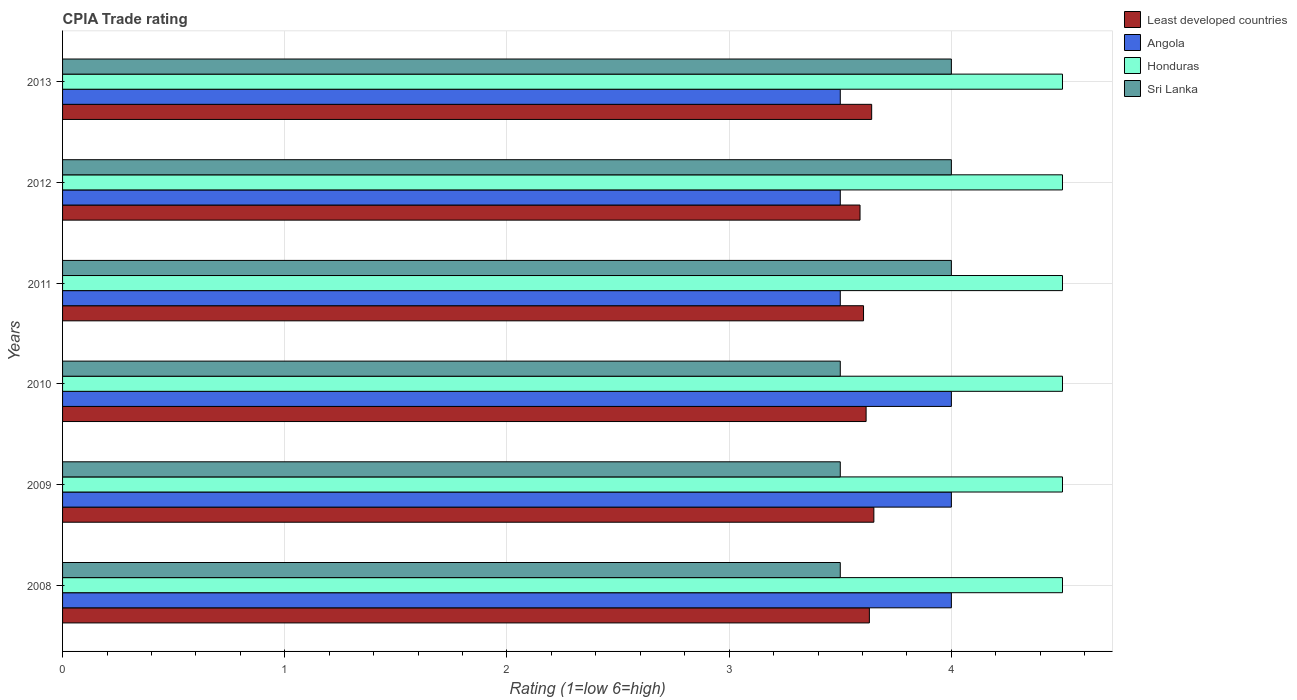How many different coloured bars are there?
Ensure brevity in your answer.  4. How many groups of bars are there?
Your answer should be very brief. 6. Are the number of bars on each tick of the Y-axis equal?
Offer a terse response. Yes. How many bars are there on the 4th tick from the bottom?
Offer a terse response. 4. What is the label of the 5th group of bars from the top?
Keep it short and to the point. 2009. In how many cases, is the number of bars for a given year not equal to the number of legend labels?
Offer a terse response. 0. Across all years, what is the minimum CPIA rating in Honduras?
Ensure brevity in your answer.  4.5. In which year was the CPIA rating in Honduras maximum?
Ensure brevity in your answer.  2008. What is the difference between the CPIA rating in Least developed countries in 2011 and that in 2013?
Keep it short and to the point. -0.04. What is the average CPIA rating in Sri Lanka per year?
Ensure brevity in your answer.  3.75. In the year 2008, what is the difference between the CPIA rating in Sri Lanka and CPIA rating in Least developed countries?
Offer a terse response. -0.13. In how many years, is the CPIA rating in Honduras greater than 2 ?
Give a very brief answer. 6. What is the ratio of the CPIA rating in Angola in 2012 to that in 2013?
Your response must be concise. 1. What is the difference between the highest and the second highest CPIA rating in Least developed countries?
Offer a terse response. 0.01. What is the difference between the highest and the lowest CPIA rating in Sri Lanka?
Ensure brevity in your answer.  0.5. In how many years, is the CPIA rating in Least developed countries greater than the average CPIA rating in Least developed countries taken over all years?
Make the answer very short. 3. Is it the case that in every year, the sum of the CPIA rating in Honduras and CPIA rating in Sri Lanka is greater than the sum of CPIA rating in Angola and CPIA rating in Least developed countries?
Give a very brief answer. Yes. What does the 1st bar from the top in 2009 represents?
Ensure brevity in your answer.  Sri Lanka. What does the 1st bar from the bottom in 2013 represents?
Provide a succinct answer. Least developed countries. Is it the case that in every year, the sum of the CPIA rating in Sri Lanka and CPIA rating in Honduras is greater than the CPIA rating in Least developed countries?
Offer a very short reply. Yes. Are all the bars in the graph horizontal?
Your response must be concise. Yes. What is the difference between two consecutive major ticks on the X-axis?
Your answer should be compact. 1. Are the values on the major ticks of X-axis written in scientific E-notation?
Give a very brief answer. No. Does the graph contain grids?
Offer a very short reply. Yes. Where does the legend appear in the graph?
Your answer should be compact. Top right. How many legend labels are there?
Ensure brevity in your answer.  4. What is the title of the graph?
Give a very brief answer. CPIA Trade rating. What is the label or title of the X-axis?
Provide a short and direct response. Rating (1=low 6=high). What is the label or title of the Y-axis?
Your response must be concise. Years. What is the Rating (1=low 6=high) in Least developed countries in 2008?
Provide a short and direct response. 3.63. What is the Rating (1=low 6=high) of Honduras in 2008?
Offer a terse response. 4.5. What is the Rating (1=low 6=high) of Sri Lanka in 2008?
Make the answer very short. 3.5. What is the Rating (1=low 6=high) of Least developed countries in 2009?
Keep it short and to the point. 3.65. What is the Rating (1=low 6=high) of Angola in 2009?
Your response must be concise. 4. What is the Rating (1=low 6=high) in Honduras in 2009?
Make the answer very short. 4.5. What is the Rating (1=low 6=high) of Least developed countries in 2010?
Your response must be concise. 3.62. What is the Rating (1=low 6=high) of Angola in 2010?
Give a very brief answer. 4. What is the Rating (1=low 6=high) of Least developed countries in 2011?
Your response must be concise. 3.6. What is the Rating (1=low 6=high) of Angola in 2011?
Provide a succinct answer. 3.5. What is the Rating (1=low 6=high) of Honduras in 2011?
Offer a terse response. 4.5. What is the Rating (1=low 6=high) of Least developed countries in 2012?
Your response must be concise. 3.59. What is the Rating (1=low 6=high) of Sri Lanka in 2012?
Offer a terse response. 4. What is the Rating (1=low 6=high) of Least developed countries in 2013?
Offer a very short reply. 3.64. What is the Rating (1=low 6=high) in Angola in 2013?
Your answer should be compact. 3.5. What is the Rating (1=low 6=high) in Sri Lanka in 2013?
Offer a very short reply. 4. Across all years, what is the maximum Rating (1=low 6=high) of Least developed countries?
Make the answer very short. 3.65. Across all years, what is the maximum Rating (1=low 6=high) in Angola?
Offer a terse response. 4. Across all years, what is the maximum Rating (1=low 6=high) of Honduras?
Provide a succinct answer. 4.5. Across all years, what is the maximum Rating (1=low 6=high) of Sri Lanka?
Provide a short and direct response. 4. Across all years, what is the minimum Rating (1=low 6=high) in Least developed countries?
Keep it short and to the point. 3.59. Across all years, what is the minimum Rating (1=low 6=high) in Angola?
Give a very brief answer. 3.5. Across all years, what is the minimum Rating (1=low 6=high) of Honduras?
Your answer should be very brief. 4.5. What is the total Rating (1=low 6=high) in Least developed countries in the graph?
Provide a short and direct response. 21.73. What is the total Rating (1=low 6=high) of Angola in the graph?
Your answer should be compact. 22.5. What is the total Rating (1=low 6=high) of Sri Lanka in the graph?
Offer a terse response. 22.5. What is the difference between the Rating (1=low 6=high) in Least developed countries in 2008 and that in 2009?
Ensure brevity in your answer.  -0.02. What is the difference between the Rating (1=low 6=high) of Honduras in 2008 and that in 2009?
Offer a very short reply. 0. What is the difference between the Rating (1=low 6=high) of Least developed countries in 2008 and that in 2010?
Ensure brevity in your answer.  0.01. What is the difference between the Rating (1=low 6=high) in Angola in 2008 and that in 2010?
Ensure brevity in your answer.  0. What is the difference between the Rating (1=low 6=high) of Honduras in 2008 and that in 2010?
Keep it short and to the point. 0. What is the difference between the Rating (1=low 6=high) of Least developed countries in 2008 and that in 2011?
Your answer should be compact. 0.03. What is the difference between the Rating (1=low 6=high) in Honduras in 2008 and that in 2011?
Offer a very short reply. 0. What is the difference between the Rating (1=low 6=high) of Least developed countries in 2008 and that in 2012?
Provide a short and direct response. 0.04. What is the difference between the Rating (1=low 6=high) in Honduras in 2008 and that in 2012?
Provide a succinct answer. 0. What is the difference between the Rating (1=low 6=high) of Least developed countries in 2008 and that in 2013?
Your response must be concise. -0.01. What is the difference between the Rating (1=low 6=high) in Honduras in 2008 and that in 2013?
Give a very brief answer. 0. What is the difference between the Rating (1=low 6=high) of Least developed countries in 2009 and that in 2010?
Your response must be concise. 0.03. What is the difference between the Rating (1=low 6=high) in Angola in 2009 and that in 2010?
Your answer should be compact. 0. What is the difference between the Rating (1=low 6=high) of Sri Lanka in 2009 and that in 2010?
Your response must be concise. 0. What is the difference between the Rating (1=low 6=high) in Least developed countries in 2009 and that in 2011?
Your response must be concise. 0.05. What is the difference between the Rating (1=low 6=high) of Angola in 2009 and that in 2011?
Provide a short and direct response. 0.5. What is the difference between the Rating (1=low 6=high) of Honduras in 2009 and that in 2011?
Offer a terse response. 0. What is the difference between the Rating (1=low 6=high) in Sri Lanka in 2009 and that in 2011?
Provide a short and direct response. -0.5. What is the difference between the Rating (1=low 6=high) of Least developed countries in 2009 and that in 2012?
Your response must be concise. 0.06. What is the difference between the Rating (1=low 6=high) of Angola in 2009 and that in 2012?
Your answer should be compact. 0.5. What is the difference between the Rating (1=low 6=high) in Sri Lanka in 2009 and that in 2012?
Offer a terse response. -0.5. What is the difference between the Rating (1=low 6=high) in Least developed countries in 2009 and that in 2013?
Make the answer very short. 0.01. What is the difference between the Rating (1=low 6=high) of Least developed countries in 2010 and that in 2011?
Your answer should be compact. 0.01. What is the difference between the Rating (1=low 6=high) of Least developed countries in 2010 and that in 2012?
Provide a succinct answer. 0.03. What is the difference between the Rating (1=low 6=high) of Sri Lanka in 2010 and that in 2012?
Make the answer very short. -0.5. What is the difference between the Rating (1=low 6=high) of Least developed countries in 2010 and that in 2013?
Make the answer very short. -0.03. What is the difference between the Rating (1=low 6=high) in Angola in 2010 and that in 2013?
Offer a terse response. 0.5. What is the difference between the Rating (1=low 6=high) of Honduras in 2010 and that in 2013?
Provide a short and direct response. 0. What is the difference between the Rating (1=low 6=high) in Sri Lanka in 2010 and that in 2013?
Make the answer very short. -0.5. What is the difference between the Rating (1=low 6=high) in Least developed countries in 2011 and that in 2012?
Make the answer very short. 0.02. What is the difference between the Rating (1=low 6=high) of Honduras in 2011 and that in 2012?
Keep it short and to the point. 0. What is the difference between the Rating (1=low 6=high) of Sri Lanka in 2011 and that in 2012?
Provide a succinct answer. 0. What is the difference between the Rating (1=low 6=high) in Least developed countries in 2011 and that in 2013?
Your response must be concise. -0.04. What is the difference between the Rating (1=low 6=high) of Angola in 2011 and that in 2013?
Your answer should be compact. 0. What is the difference between the Rating (1=low 6=high) in Sri Lanka in 2011 and that in 2013?
Offer a very short reply. 0. What is the difference between the Rating (1=low 6=high) in Least developed countries in 2012 and that in 2013?
Make the answer very short. -0.05. What is the difference between the Rating (1=low 6=high) of Honduras in 2012 and that in 2013?
Provide a succinct answer. 0. What is the difference between the Rating (1=low 6=high) in Sri Lanka in 2012 and that in 2013?
Provide a succinct answer. 0. What is the difference between the Rating (1=low 6=high) of Least developed countries in 2008 and the Rating (1=low 6=high) of Angola in 2009?
Your response must be concise. -0.37. What is the difference between the Rating (1=low 6=high) in Least developed countries in 2008 and the Rating (1=low 6=high) in Honduras in 2009?
Your answer should be compact. -0.87. What is the difference between the Rating (1=low 6=high) in Least developed countries in 2008 and the Rating (1=low 6=high) in Sri Lanka in 2009?
Your answer should be very brief. 0.13. What is the difference between the Rating (1=low 6=high) of Least developed countries in 2008 and the Rating (1=low 6=high) of Angola in 2010?
Provide a short and direct response. -0.37. What is the difference between the Rating (1=low 6=high) in Least developed countries in 2008 and the Rating (1=low 6=high) in Honduras in 2010?
Your answer should be very brief. -0.87. What is the difference between the Rating (1=low 6=high) of Least developed countries in 2008 and the Rating (1=low 6=high) of Sri Lanka in 2010?
Provide a succinct answer. 0.13. What is the difference between the Rating (1=low 6=high) of Angola in 2008 and the Rating (1=low 6=high) of Sri Lanka in 2010?
Offer a terse response. 0.5. What is the difference between the Rating (1=low 6=high) in Least developed countries in 2008 and the Rating (1=low 6=high) in Angola in 2011?
Your answer should be compact. 0.13. What is the difference between the Rating (1=low 6=high) of Least developed countries in 2008 and the Rating (1=low 6=high) of Honduras in 2011?
Ensure brevity in your answer.  -0.87. What is the difference between the Rating (1=low 6=high) of Least developed countries in 2008 and the Rating (1=low 6=high) of Sri Lanka in 2011?
Ensure brevity in your answer.  -0.37. What is the difference between the Rating (1=low 6=high) in Least developed countries in 2008 and the Rating (1=low 6=high) in Angola in 2012?
Your answer should be compact. 0.13. What is the difference between the Rating (1=low 6=high) in Least developed countries in 2008 and the Rating (1=low 6=high) in Honduras in 2012?
Your answer should be compact. -0.87. What is the difference between the Rating (1=low 6=high) of Least developed countries in 2008 and the Rating (1=low 6=high) of Sri Lanka in 2012?
Keep it short and to the point. -0.37. What is the difference between the Rating (1=low 6=high) of Honduras in 2008 and the Rating (1=low 6=high) of Sri Lanka in 2012?
Your answer should be compact. 0.5. What is the difference between the Rating (1=low 6=high) of Least developed countries in 2008 and the Rating (1=low 6=high) of Angola in 2013?
Offer a very short reply. 0.13. What is the difference between the Rating (1=low 6=high) of Least developed countries in 2008 and the Rating (1=low 6=high) of Honduras in 2013?
Give a very brief answer. -0.87. What is the difference between the Rating (1=low 6=high) in Least developed countries in 2008 and the Rating (1=low 6=high) in Sri Lanka in 2013?
Provide a succinct answer. -0.37. What is the difference between the Rating (1=low 6=high) in Angola in 2008 and the Rating (1=low 6=high) in Honduras in 2013?
Provide a short and direct response. -0.5. What is the difference between the Rating (1=low 6=high) of Honduras in 2008 and the Rating (1=low 6=high) of Sri Lanka in 2013?
Give a very brief answer. 0.5. What is the difference between the Rating (1=low 6=high) in Least developed countries in 2009 and the Rating (1=low 6=high) in Angola in 2010?
Your answer should be very brief. -0.35. What is the difference between the Rating (1=low 6=high) in Least developed countries in 2009 and the Rating (1=low 6=high) in Honduras in 2010?
Provide a succinct answer. -0.85. What is the difference between the Rating (1=low 6=high) of Least developed countries in 2009 and the Rating (1=low 6=high) of Sri Lanka in 2010?
Provide a short and direct response. 0.15. What is the difference between the Rating (1=low 6=high) in Angola in 2009 and the Rating (1=low 6=high) in Honduras in 2010?
Give a very brief answer. -0.5. What is the difference between the Rating (1=low 6=high) in Honduras in 2009 and the Rating (1=low 6=high) in Sri Lanka in 2010?
Ensure brevity in your answer.  1. What is the difference between the Rating (1=low 6=high) of Least developed countries in 2009 and the Rating (1=low 6=high) of Angola in 2011?
Provide a short and direct response. 0.15. What is the difference between the Rating (1=low 6=high) in Least developed countries in 2009 and the Rating (1=low 6=high) in Honduras in 2011?
Your response must be concise. -0.85. What is the difference between the Rating (1=low 6=high) of Least developed countries in 2009 and the Rating (1=low 6=high) of Sri Lanka in 2011?
Give a very brief answer. -0.35. What is the difference between the Rating (1=low 6=high) in Angola in 2009 and the Rating (1=low 6=high) in Honduras in 2011?
Offer a terse response. -0.5. What is the difference between the Rating (1=low 6=high) of Angola in 2009 and the Rating (1=low 6=high) of Sri Lanka in 2011?
Your answer should be compact. 0. What is the difference between the Rating (1=low 6=high) of Honduras in 2009 and the Rating (1=low 6=high) of Sri Lanka in 2011?
Your answer should be very brief. 0.5. What is the difference between the Rating (1=low 6=high) of Least developed countries in 2009 and the Rating (1=low 6=high) of Angola in 2012?
Offer a terse response. 0.15. What is the difference between the Rating (1=low 6=high) in Least developed countries in 2009 and the Rating (1=low 6=high) in Honduras in 2012?
Ensure brevity in your answer.  -0.85. What is the difference between the Rating (1=low 6=high) of Least developed countries in 2009 and the Rating (1=low 6=high) of Sri Lanka in 2012?
Provide a short and direct response. -0.35. What is the difference between the Rating (1=low 6=high) in Angola in 2009 and the Rating (1=low 6=high) in Honduras in 2012?
Offer a very short reply. -0.5. What is the difference between the Rating (1=low 6=high) in Honduras in 2009 and the Rating (1=low 6=high) in Sri Lanka in 2012?
Provide a succinct answer. 0.5. What is the difference between the Rating (1=low 6=high) in Least developed countries in 2009 and the Rating (1=low 6=high) in Angola in 2013?
Provide a succinct answer. 0.15. What is the difference between the Rating (1=low 6=high) in Least developed countries in 2009 and the Rating (1=low 6=high) in Honduras in 2013?
Give a very brief answer. -0.85. What is the difference between the Rating (1=low 6=high) in Least developed countries in 2009 and the Rating (1=low 6=high) in Sri Lanka in 2013?
Make the answer very short. -0.35. What is the difference between the Rating (1=low 6=high) in Honduras in 2009 and the Rating (1=low 6=high) in Sri Lanka in 2013?
Give a very brief answer. 0.5. What is the difference between the Rating (1=low 6=high) of Least developed countries in 2010 and the Rating (1=low 6=high) of Angola in 2011?
Make the answer very short. 0.12. What is the difference between the Rating (1=low 6=high) of Least developed countries in 2010 and the Rating (1=low 6=high) of Honduras in 2011?
Your answer should be compact. -0.88. What is the difference between the Rating (1=low 6=high) of Least developed countries in 2010 and the Rating (1=low 6=high) of Sri Lanka in 2011?
Your answer should be very brief. -0.38. What is the difference between the Rating (1=low 6=high) in Angola in 2010 and the Rating (1=low 6=high) in Honduras in 2011?
Your answer should be compact. -0.5. What is the difference between the Rating (1=low 6=high) of Angola in 2010 and the Rating (1=low 6=high) of Sri Lanka in 2011?
Offer a terse response. 0. What is the difference between the Rating (1=low 6=high) of Honduras in 2010 and the Rating (1=low 6=high) of Sri Lanka in 2011?
Give a very brief answer. 0.5. What is the difference between the Rating (1=low 6=high) of Least developed countries in 2010 and the Rating (1=low 6=high) of Angola in 2012?
Ensure brevity in your answer.  0.12. What is the difference between the Rating (1=low 6=high) of Least developed countries in 2010 and the Rating (1=low 6=high) of Honduras in 2012?
Your answer should be compact. -0.88. What is the difference between the Rating (1=low 6=high) of Least developed countries in 2010 and the Rating (1=low 6=high) of Sri Lanka in 2012?
Your response must be concise. -0.38. What is the difference between the Rating (1=low 6=high) of Angola in 2010 and the Rating (1=low 6=high) of Honduras in 2012?
Keep it short and to the point. -0.5. What is the difference between the Rating (1=low 6=high) of Angola in 2010 and the Rating (1=low 6=high) of Sri Lanka in 2012?
Your answer should be very brief. 0. What is the difference between the Rating (1=low 6=high) in Honduras in 2010 and the Rating (1=low 6=high) in Sri Lanka in 2012?
Your answer should be very brief. 0.5. What is the difference between the Rating (1=low 6=high) of Least developed countries in 2010 and the Rating (1=low 6=high) of Angola in 2013?
Your answer should be very brief. 0.12. What is the difference between the Rating (1=low 6=high) of Least developed countries in 2010 and the Rating (1=low 6=high) of Honduras in 2013?
Your answer should be very brief. -0.88. What is the difference between the Rating (1=low 6=high) in Least developed countries in 2010 and the Rating (1=low 6=high) in Sri Lanka in 2013?
Your answer should be compact. -0.38. What is the difference between the Rating (1=low 6=high) of Honduras in 2010 and the Rating (1=low 6=high) of Sri Lanka in 2013?
Provide a succinct answer. 0.5. What is the difference between the Rating (1=low 6=high) in Least developed countries in 2011 and the Rating (1=low 6=high) in Angola in 2012?
Your answer should be compact. 0.1. What is the difference between the Rating (1=low 6=high) of Least developed countries in 2011 and the Rating (1=low 6=high) of Honduras in 2012?
Your answer should be very brief. -0.9. What is the difference between the Rating (1=low 6=high) of Least developed countries in 2011 and the Rating (1=low 6=high) of Sri Lanka in 2012?
Provide a succinct answer. -0.4. What is the difference between the Rating (1=low 6=high) in Angola in 2011 and the Rating (1=low 6=high) in Honduras in 2012?
Keep it short and to the point. -1. What is the difference between the Rating (1=low 6=high) in Angola in 2011 and the Rating (1=low 6=high) in Sri Lanka in 2012?
Keep it short and to the point. -0.5. What is the difference between the Rating (1=low 6=high) of Honduras in 2011 and the Rating (1=low 6=high) of Sri Lanka in 2012?
Offer a terse response. 0.5. What is the difference between the Rating (1=low 6=high) of Least developed countries in 2011 and the Rating (1=low 6=high) of Angola in 2013?
Provide a short and direct response. 0.1. What is the difference between the Rating (1=low 6=high) in Least developed countries in 2011 and the Rating (1=low 6=high) in Honduras in 2013?
Your response must be concise. -0.9. What is the difference between the Rating (1=low 6=high) in Least developed countries in 2011 and the Rating (1=low 6=high) in Sri Lanka in 2013?
Offer a terse response. -0.4. What is the difference between the Rating (1=low 6=high) in Angola in 2011 and the Rating (1=low 6=high) in Honduras in 2013?
Your response must be concise. -1. What is the difference between the Rating (1=low 6=high) in Angola in 2011 and the Rating (1=low 6=high) in Sri Lanka in 2013?
Offer a terse response. -0.5. What is the difference between the Rating (1=low 6=high) in Honduras in 2011 and the Rating (1=low 6=high) in Sri Lanka in 2013?
Provide a short and direct response. 0.5. What is the difference between the Rating (1=low 6=high) of Least developed countries in 2012 and the Rating (1=low 6=high) of Angola in 2013?
Provide a short and direct response. 0.09. What is the difference between the Rating (1=low 6=high) of Least developed countries in 2012 and the Rating (1=low 6=high) of Honduras in 2013?
Your response must be concise. -0.91. What is the difference between the Rating (1=low 6=high) of Least developed countries in 2012 and the Rating (1=low 6=high) of Sri Lanka in 2013?
Keep it short and to the point. -0.41. What is the difference between the Rating (1=low 6=high) of Honduras in 2012 and the Rating (1=low 6=high) of Sri Lanka in 2013?
Ensure brevity in your answer.  0.5. What is the average Rating (1=low 6=high) in Least developed countries per year?
Your answer should be very brief. 3.62. What is the average Rating (1=low 6=high) of Angola per year?
Ensure brevity in your answer.  3.75. What is the average Rating (1=low 6=high) in Sri Lanka per year?
Ensure brevity in your answer.  3.75. In the year 2008, what is the difference between the Rating (1=low 6=high) of Least developed countries and Rating (1=low 6=high) of Angola?
Your response must be concise. -0.37. In the year 2008, what is the difference between the Rating (1=low 6=high) in Least developed countries and Rating (1=low 6=high) in Honduras?
Provide a succinct answer. -0.87. In the year 2008, what is the difference between the Rating (1=low 6=high) in Least developed countries and Rating (1=low 6=high) in Sri Lanka?
Make the answer very short. 0.13. In the year 2008, what is the difference between the Rating (1=low 6=high) of Angola and Rating (1=low 6=high) of Honduras?
Keep it short and to the point. -0.5. In the year 2008, what is the difference between the Rating (1=low 6=high) of Honduras and Rating (1=low 6=high) of Sri Lanka?
Your answer should be compact. 1. In the year 2009, what is the difference between the Rating (1=low 6=high) of Least developed countries and Rating (1=low 6=high) of Angola?
Keep it short and to the point. -0.35. In the year 2009, what is the difference between the Rating (1=low 6=high) of Least developed countries and Rating (1=low 6=high) of Honduras?
Offer a very short reply. -0.85. In the year 2009, what is the difference between the Rating (1=low 6=high) in Least developed countries and Rating (1=low 6=high) in Sri Lanka?
Make the answer very short. 0.15. In the year 2009, what is the difference between the Rating (1=low 6=high) of Angola and Rating (1=low 6=high) of Honduras?
Provide a short and direct response. -0.5. In the year 2009, what is the difference between the Rating (1=low 6=high) of Honduras and Rating (1=low 6=high) of Sri Lanka?
Your answer should be compact. 1. In the year 2010, what is the difference between the Rating (1=low 6=high) in Least developed countries and Rating (1=low 6=high) in Angola?
Your response must be concise. -0.38. In the year 2010, what is the difference between the Rating (1=low 6=high) of Least developed countries and Rating (1=low 6=high) of Honduras?
Offer a very short reply. -0.88. In the year 2010, what is the difference between the Rating (1=low 6=high) in Least developed countries and Rating (1=low 6=high) in Sri Lanka?
Make the answer very short. 0.12. In the year 2010, what is the difference between the Rating (1=low 6=high) in Angola and Rating (1=low 6=high) in Honduras?
Provide a succinct answer. -0.5. In the year 2011, what is the difference between the Rating (1=low 6=high) of Least developed countries and Rating (1=low 6=high) of Angola?
Offer a terse response. 0.1. In the year 2011, what is the difference between the Rating (1=low 6=high) of Least developed countries and Rating (1=low 6=high) of Honduras?
Your answer should be very brief. -0.9. In the year 2011, what is the difference between the Rating (1=low 6=high) of Least developed countries and Rating (1=low 6=high) of Sri Lanka?
Your answer should be compact. -0.4. In the year 2011, what is the difference between the Rating (1=low 6=high) of Angola and Rating (1=low 6=high) of Honduras?
Offer a terse response. -1. In the year 2011, what is the difference between the Rating (1=low 6=high) of Angola and Rating (1=low 6=high) of Sri Lanka?
Keep it short and to the point. -0.5. In the year 2012, what is the difference between the Rating (1=low 6=high) of Least developed countries and Rating (1=low 6=high) of Angola?
Your answer should be very brief. 0.09. In the year 2012, what is the difference between the Rating (1=low 6=high) in Least developed countries and Rating (1=low 6=high) in Honduras?
Your answer should be compact. -0.91. In the year 2012, what is the difference between the Rating (1=low 6=high) of Least developed countries and Rating (1=low 6=high) of Sri Lanka?
Ensure brevity in your answer.  -0.41. In the year 2012, what is the difference between the Rating (1=low 6=high) of Angola and Rating (1=low 6=high) of Honduras?
Keep it short and to the point. -1. In the year 2012, what is the difference between the Rating (1=low 6=high) in Honduras and Rating (1=low 6=high) in Sri Lanka?
Your answer should be very brief. 0.5. In the year 2013, what is the difference between the Rating (1=low 6=high) in Least developed countries and Rating (1=low 6=high) in Angola?
Offer a very short reply. 0.14. In the year 2013, what is the difference between the Rating (1=low 6=high) in Least developed countries and Rating (1=low 6=high) in Honduras?
Your response must be concise. -0.86. In the year 2013, what is the difference between the Rating (1=low 6=high) in Least developed countries and Rating (1=low 6=high) in Sri Lanka?
Provide a succinct answer. -0.36. In the year 2013, what is the difference between the Rating (1=low 6=high) of Angola and Rating (1=low 6=high) of Honduras?
Your response must be concise. -1. In the year 2013, what is the difference between the Rating (1=low 6=high) in Angola and Rating (1=low 6=high) in Sri Lanka?
Provide a succinct answer. -0.5. In the year 2013, what is the difference between the Rating (1=low 6=high) in Honduras and Rating (1=low 6=high) in Sri Lanka?
Your answer should be very brief. 0.5. What is the ratio of the Rating (1=low 6=high) in Least developed countries in 2008 to that in 2009?
Provide a succinct answer. 0.99. What is the ratio of the Rating (1=low 6=high) of Honduras in 2008 to that in 2009?
Keep it short and to the point. 1. What is the ratio of the Rating (1=low 6=high) in Least developed countries in 2008 to that in 2010?
Provide a short and direct response. 1. What is the ratio of the Rating (1=low 6=high) of Angola in 2008 to that in 2010?
Offer a terse response. 1. What is the ratio of the Rating (1=low 6=high) of Least developed countries in 2008 to that in 2011?
Your answer should be very brief. 1.01. What is the ratio of the Rating (1=low 6=high) of Angola in 2008 to that in 2011?
Give a very brief answer. 1.14. What is the ratio of the Rating (1=low 6=high) of Sri Lanka in 2008 to that in 2011?
Provide a succinct answer. 0.88. What is the ratio of the Rating (1=low 6=high) in Least developed countries in 2008 to that in 2012?
Your answer should be very brief. 1.01. What is the ratio of the Rating (1=low 6=high) of Angola in 2008 to that in 2012?
Your answer should be very brief. 1.14. What is the ratio of the Rating (1=low 6=high) of Sri Lanka in 2008 to that in 2012?
Your answer should be compact. 0.88. What is the ratio of the Rating (1=low 6=high) of Angola in 2008 to that in 2013?
Ensure brevity in your answer.  1.14. What is the ratio of the Rating (1=low 6=high) in Honduras in 2008 to that in 2013?
Offer a very short reply. 1. What is the ratio of the Rating (1=low 6=high) in Sri Lanka in 2008 to that in 2013?
Give a very brief answer. 0.88. What is the ratio of the Rating (1=low 6=high) of Least developed countries in 2009 to that in 2010?
Keep it short and to the point. 1.01. What is the ratio of the Rating (1=low 6=high) of Angola in 2009 to that in 2010?
Offer a terse response. 1. What is the ratio of the Rating (1=low 6=high) in Least developed countries in 2009 to that in 2011?
Your answer should be compact. 1.01. What is the ratio of the Rating (1=low 6=high) of Angola in 2009 to that in 2011?
Keep it short and to the point. 1.14. What is the ratio of the Rating (1=low 6=high) in Honduras in 2009 to that in 2011?
Provide a succinct answer. 1. What is the ratio of the Rating (1=low 6=high) in Sri Lanka in 2009 to that in 2011?
Offer a terse response. 0.88. What is the ratio of the Rating (1=low 6=high) of Least developed countries in 2009 to that in 2012?
Offer a very short reply. 1.02. What is the ratio of the Rating (1=low 6=high) in Angola in 2009 to that in 2012?
Keep it short and to the point. 1.14. What is the ratio of the Rating (1=low 6=high) in Honduras in 2009 to that in 2012?
Give a very brief answer. 1. What is the ratio of the Rating (1=low 6=high) of Sri Lanka in 2009 to that in 2012?
Your answer should be compact. 0.88. What is the ratio of the Rating (1=low 6=high) in Angola in 2009 to that in 2013?
Ensure brevity in your answer.  1.14. What is the ratio of the Rating (1=low 6=high) in Honduras in 2010 to that in 2011?
Offer a very short reply. 1. What is the ratio of the Rating (1=low 6=high) of Least developed countries in 2010 to that in 2012?
Make the answer very short. 1.01. What is the ratio of the Rating (1=low 6=high) of Angola in 2010 to that in 2012?
Offer a very short reply. 1.14. What is the ratio of the Rating (1=low 6=high) of Honduras in 2010 to that in 2012?
Your answer should be compact. 1. What is the ratio of the Rating (1=low 6=high) in Least developed countries in 2010 to that in 2013?
Ensure brevity in your answer.  0.99. What is the ratio of the Rating (1=low 6=high) in Angola in 2010 to that in 2013?
Offer a very short reply. 1.14. What is the ratio of the Rating (1=low 6=high) in Honduras in 2010 to that in 2013?
Your response must be concise. 1. What is the ratio of the Rating (1=low 6=high) in Least developed countries in 2011 to that in 2012?
Your answer should be very brief. 1. What is the ratio of the Rating (1=low 6=high) of Angola in 2011 to that in 2012?
Provide a short and direct response. 1. What is the ratio of the Rating (1=low 6=high) in Sri Lanka in 2011 to that in 2012?
Your response must be concise. 1. What is the ratio of the Rating (1=low 6=high) of Honduras in 2011 to that in 2013?
Your response must be concise. 1. What is the ratio of the Rating (1=low 6=high) in Sri Lanka in 2011 to that in 2013?
Your answer should be compact. 1. What is the ratio of the Rating (1=low 6=high) in Least developed countries in 2012 to that in 2013?
Ensure brevity in your answer.  0.99. What is the ratio of the Rating (1=low 6=high) of Sri Lanka in 2012 to that in 2013?
Your answer should be compact. 1. What is the difference between the highest and the second highest Rating (1=low 6=high) in Least developed countries?
Your answer should be compact. 0.01. What is the difference between the highest and the second highest Rating (1=low 6=high) of Honduras?
Your response must be concise. 0. What is the difference between the highest and the lowest Rating (1=low 6=high) of Least developed countries?
Your answer should be very brief. 0.06. What is the difference between the highest and the lowest Rating (1=low 6=high) in Angola?
Keep it short and to the point. 0.5. 